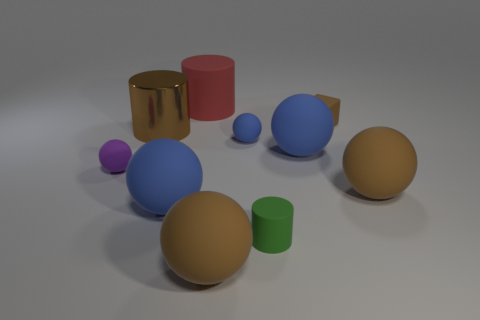Subtract all blue spheres. How many were subtracted if there are2blue spheres left? 1 Subtract all red cubes. How many blue balls are left? 3 Subtract 1 spheres. How many spheres are left? 5 Subtract all brown spheres. How many spheres are left? 4 Subtract all purple matte balls. How many balls are left? 5 Subtract all purple spheres. Subtract all green blocks. How many spheres are left? 5 Subtract all cylinders. How many objects are left? 7 Add 7 brown cylinders. How many brown cylinders are left? 8 Add 3 small green cylinders. How many small green cylinders exist? 4 Subtract 0 blue cylinders. How many objects are left? 10 